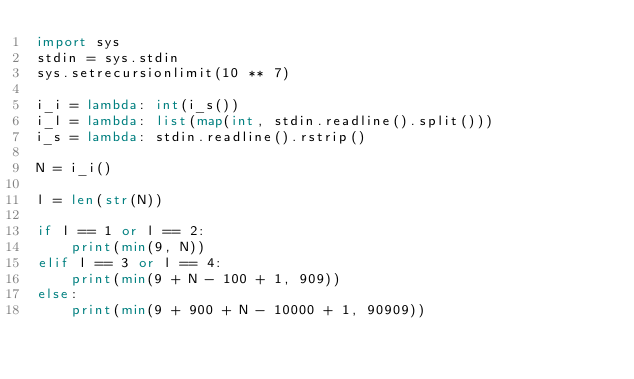<code> <loc_0><loc_0><loc_500><loc_500><_Python_>import sys
stdin = sys.stdin
sys.setrecursionlimit(10 ** 7)

i_i = lambda: int(i_s())
i_l = lambda: list(map(int, stdin.readline().split()))
i_s = lambda: stdin.readline().rstrip()

N = i_i()

l = len(str(N))

if l == 1 or l == 2:
    print(min(9, N))
elif l == 3 or l == 4:
    print(min(9 + N - 100 + 1, 909))
else:
    print(min(9 + 900 + N - 10000 + 1, 90909))
</code> 